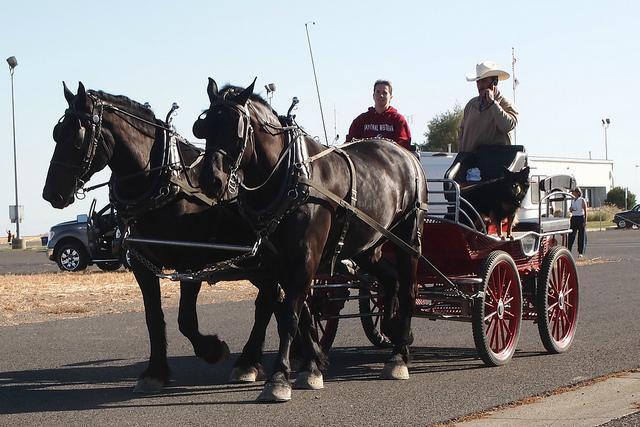How many horses are there?
Give a very brief answer. 2. How many horses are in the photo?
Give a very brief answer. 2. How many horses are pulling the carriage?
Give a very brief answer. 2. How many people are in the carriage?
Give a very brief answer. 2. How many horses are in this picture?
Give a very brief answer. 2. How many horses?
Give a very brief answer. 2. How many trucks are in the photo?
Give a very brief answer. 1. How many people are there?
Give a very brief answer. 2. How many slices of pizza are seen?
Give a very brief answer. 0. 